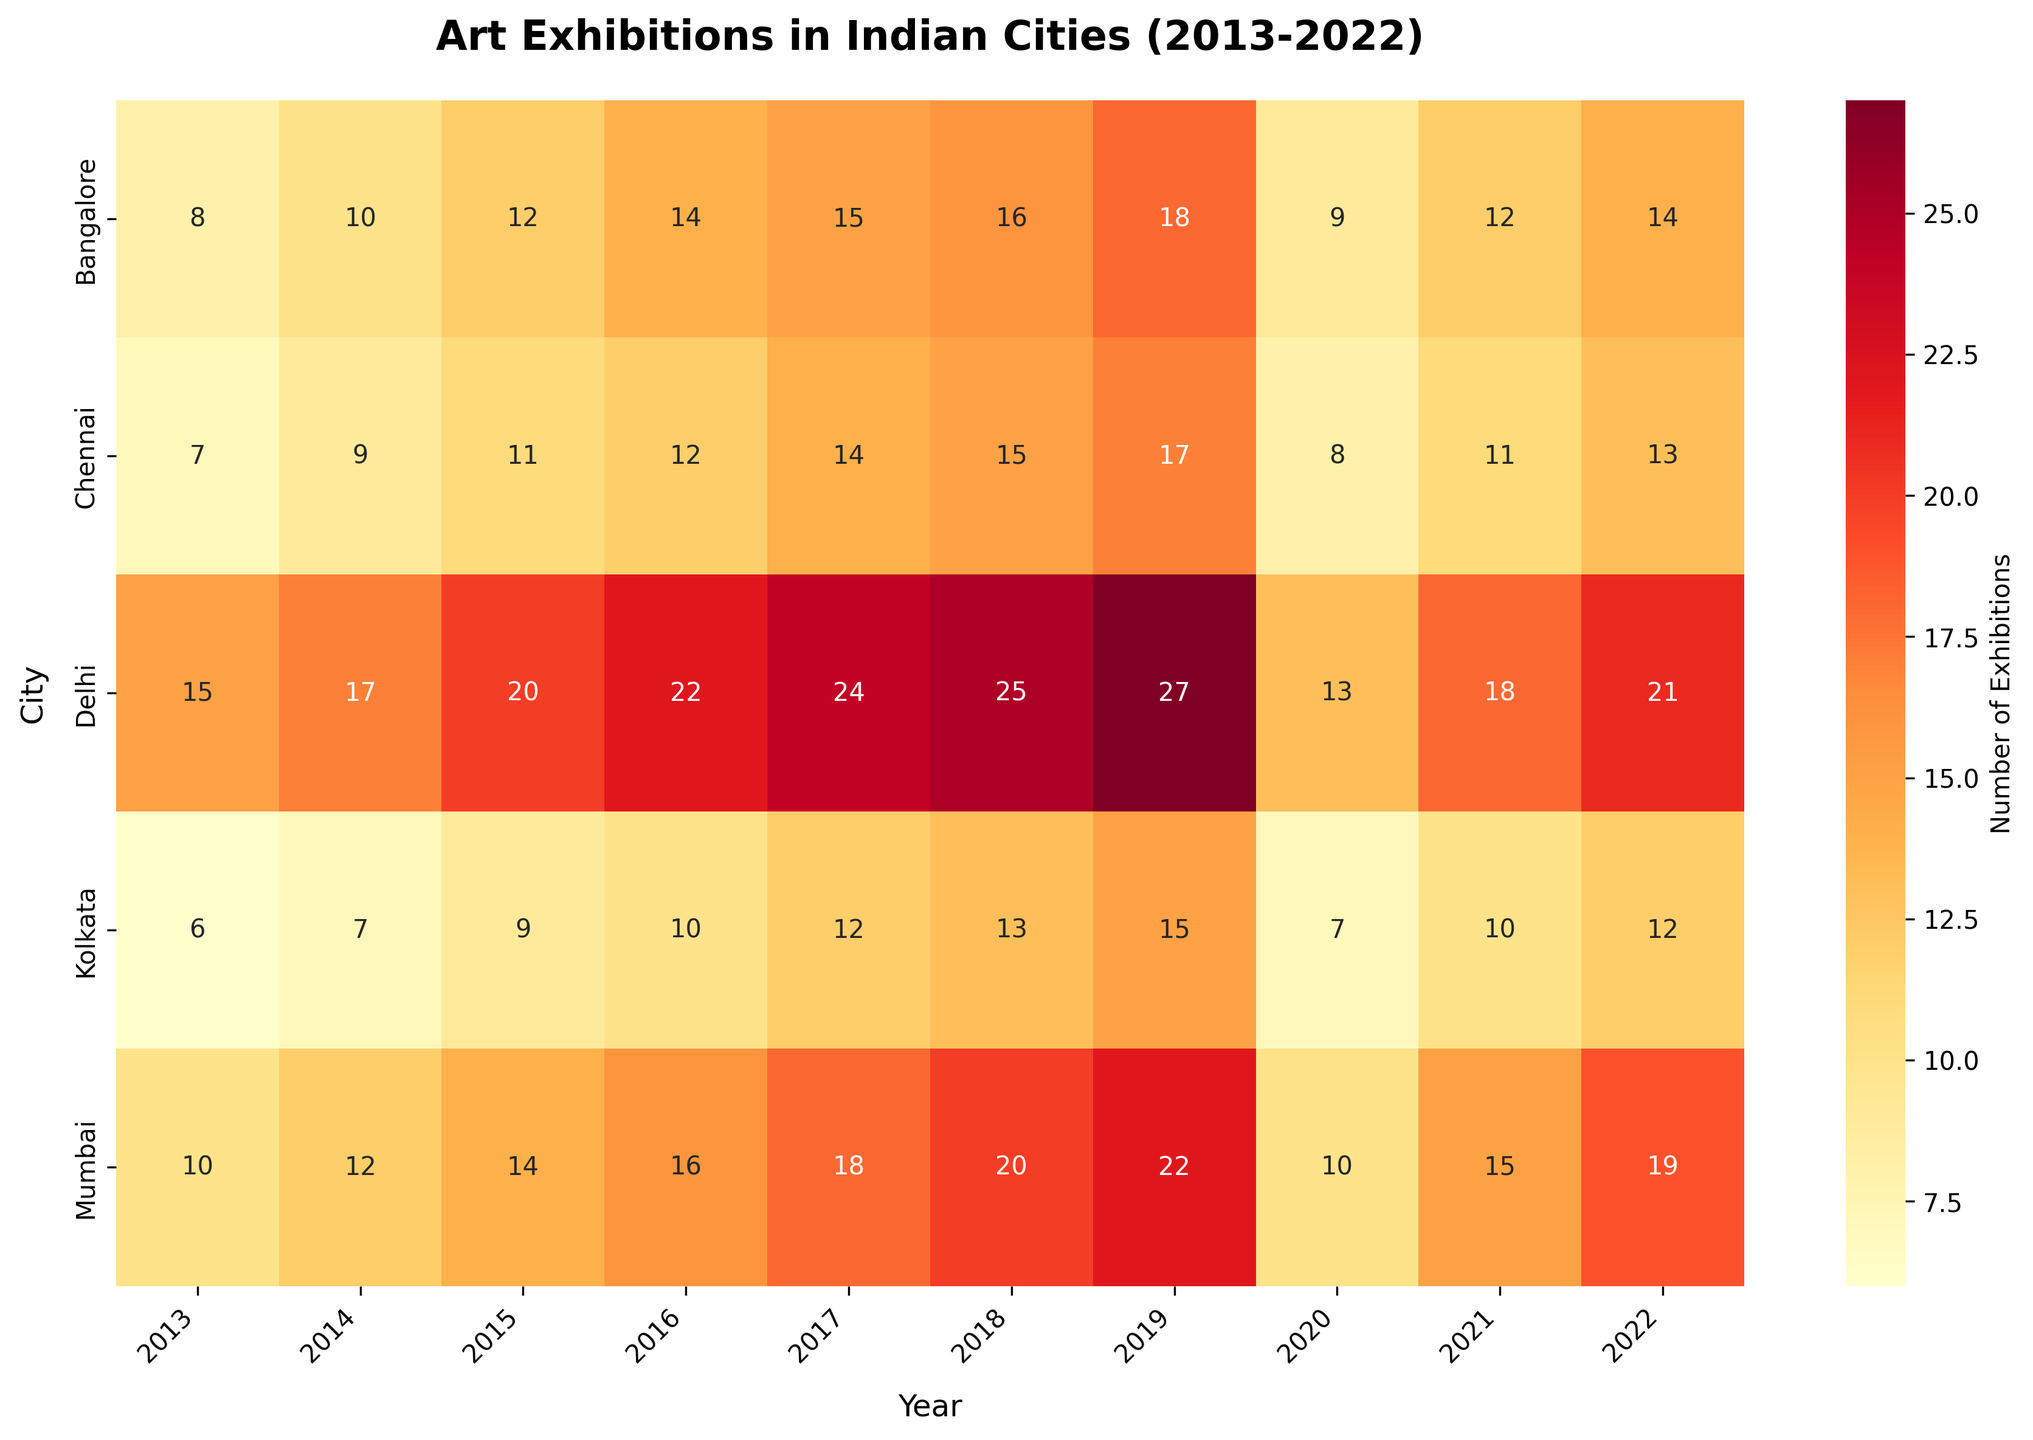What is the title of the heatmap? The title of the heatmap is displayed at the top of the figure as 'Art Exhibitions in Indian Cities (2013-2022)'
Answer: Art Exhibitions in Indian Cities (2013-2022) How many cities are represented in the heatmap? The cities are listed along the y-axis of the heatmap. The cities are Delhi, Mumbai, Bangalore, Chennai, and Kolkata.
Answer: 5 Which city had the highest number of exhibitions in any single year? To determine this, examine all the values in the heatmap and identify the highest number. The highest number is 27, which is for Delhi in 2019.
Answer: Delhi In which year did Kolkata have the lowest number of exhibitions? Examine the values corresponding to Kolkata across all years. The smallest value is 6, which occurs in 2013.
Answer: 2013 What is the overall trend of exhibitions in Mumbai from 2013 to 2022? Look at Mumbai's row and observe the numbers from 2013 to 2022. The trend shows increasing values with a drop in 2020, then rising again.
Answer: Increasing with a drop in 2020 Did any city have fewer exhibitions in 2020 compared to the previous year? For each city, compare the value in 2020 to 2019. All cities (Delhi, Mumbai, Bangalore, Chennai, Kolkata) had fewer exhibitions in 2020.
Answer: Yes Which year had the most consistent number of exhibitions across all cities? Calculate the range (difference between max and min) for each year. The smallest range indicates the most consistent year. For example: 2019 has a range of 27-15=12, whereas 2020 has a range of 13-7=6. So, 2020 has the smallest range.
Answer: 2020 How many exhibitions were held in Chennai in total over the decade? Sum up all the values in Chennai's row: 7 + 9 + 11 + 12 + 14 + 15 + 17 + 8 + 11 + 13 = 117.
Answer: 117 Which year saw the highest combined number of exhibitions across all cities? Sum the values for each year across all cities and compare. For 2019: 27 (Delhi) + 22 (Mumbai) + 18 (Bangalore) + 17 (Chennai) + 15 (Kolkata) = 99, which is the highest.
Answer: 2019 Between Bangalore and Chennai, which city had a greater increase in the number of exhibitions from 2013 to 2022? Calculate the increase for each city. Bangalore: 14-8=6, Chennai: 13-7=6. Both cities had the same increase of 6.
Answer: Both cities had the same increase 